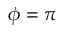<formula> <loc_0><loc_0><loc_500><loc_500>\phi = \pi</formula> 